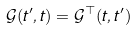Convert formula to latex. <formula><loc_0><loc_0><loc_500><loc_500>\mathcal { G } ( t ^ { \prime } , t ) = \mathcal { G } ^ { \top } ( t , t ^ { \prime } )</formula> 